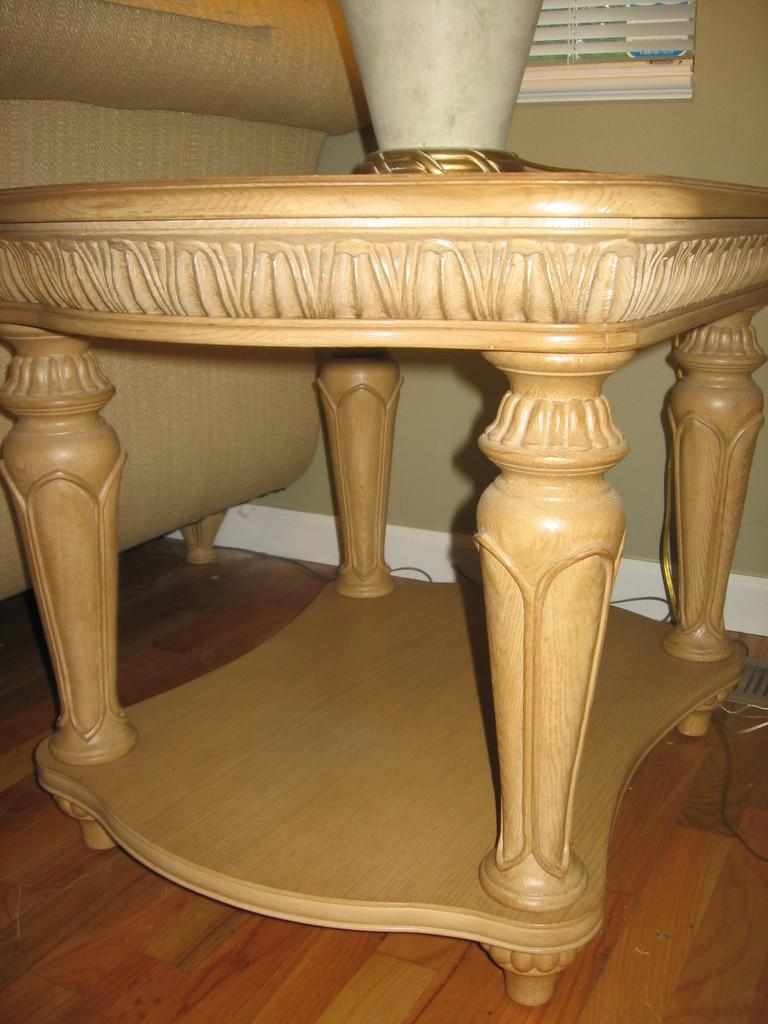What is located in the foreground of the image? There is a table in the foreground of the image. What is placed on the table? A pot is placed on the table. What can be seen in the background of the image? There is a couch, window blinds, a cable, a wall, and the floor visible in the background of the image. What color are the cats playing by the river in the image? There are no cats or rivers present in the image. What type of river can be seen in the background of the image? There is no river present in the image; it features a table, a pot, a couch, window blinds, a cable, a wall, and the floor. 